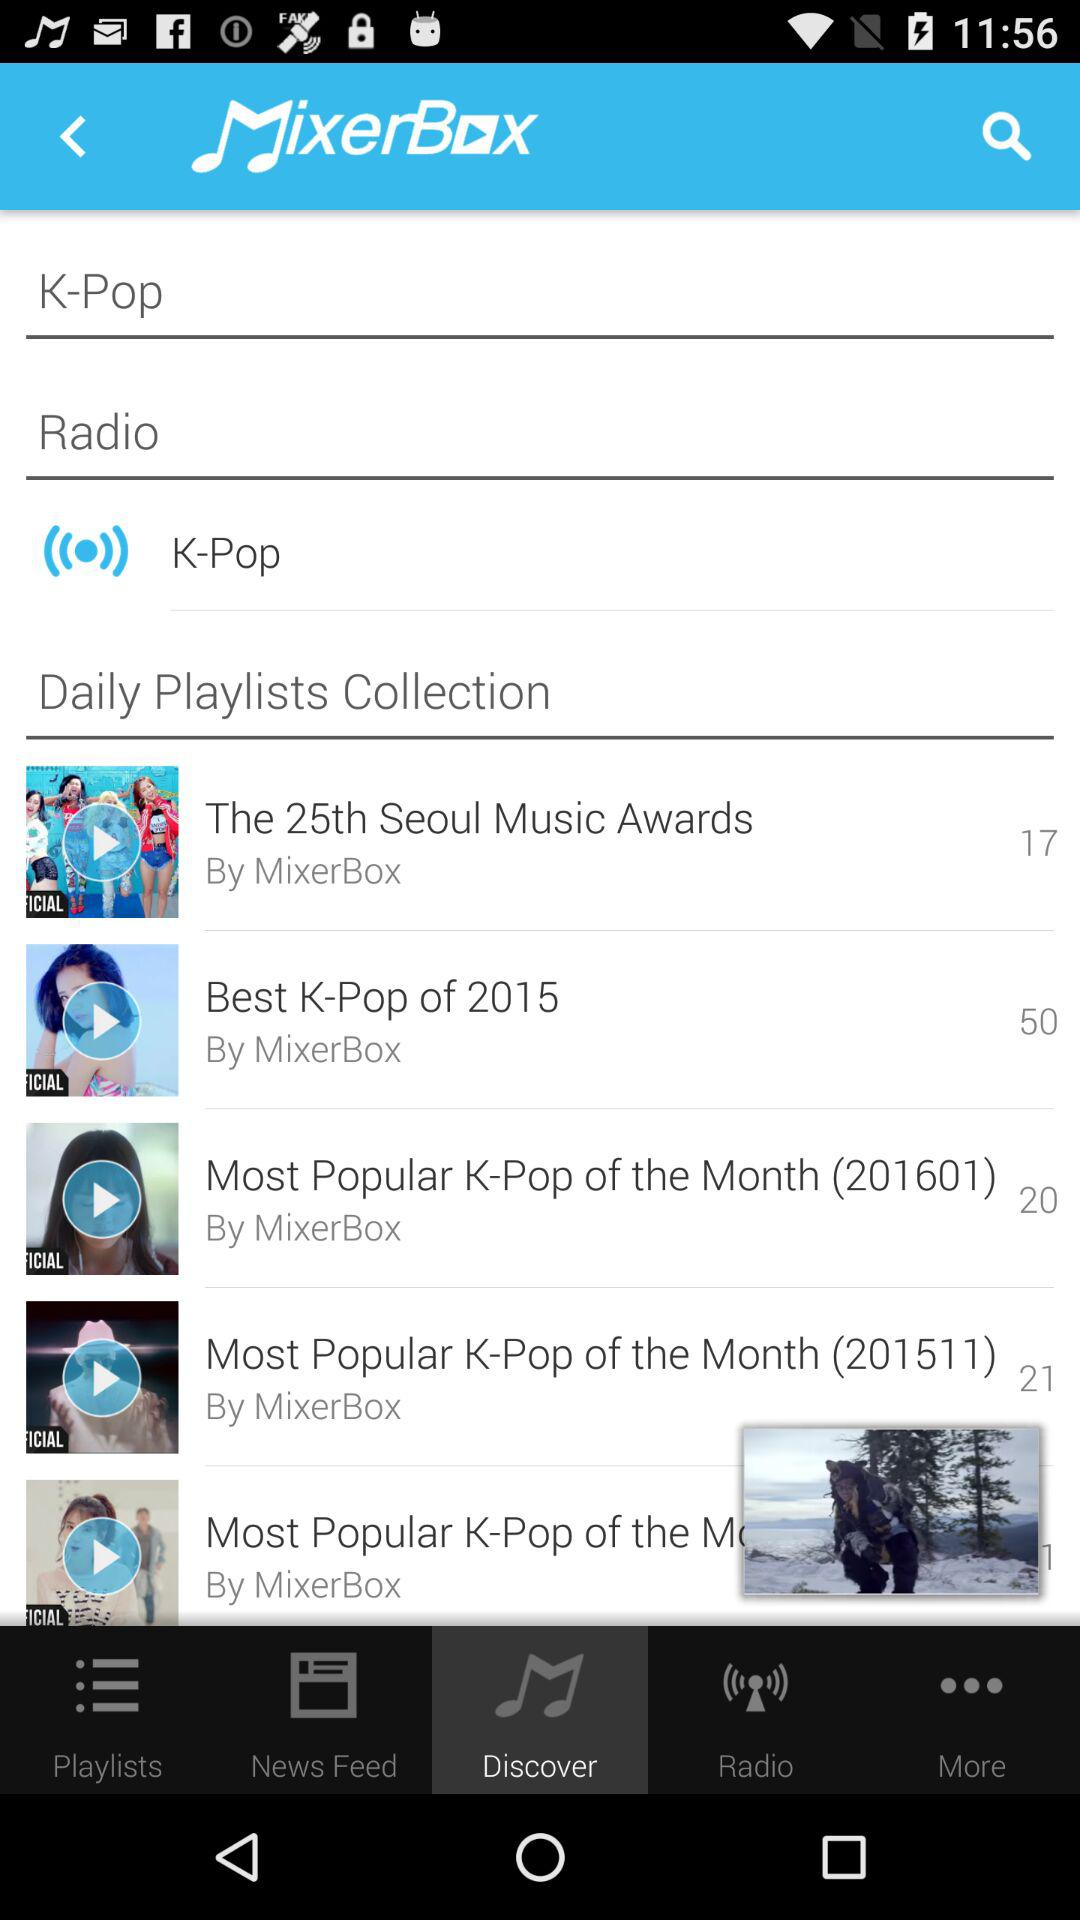What is the application name? The application name is "MixerBox". 